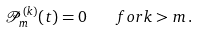Convert formula to latex. <formula><loc_0><loc_0><loc_500><loc_500>\mathcal { P } _ { m } ^ { ( k ) } ( t ) = 0 \quad f o r k > m \, .</formula> 